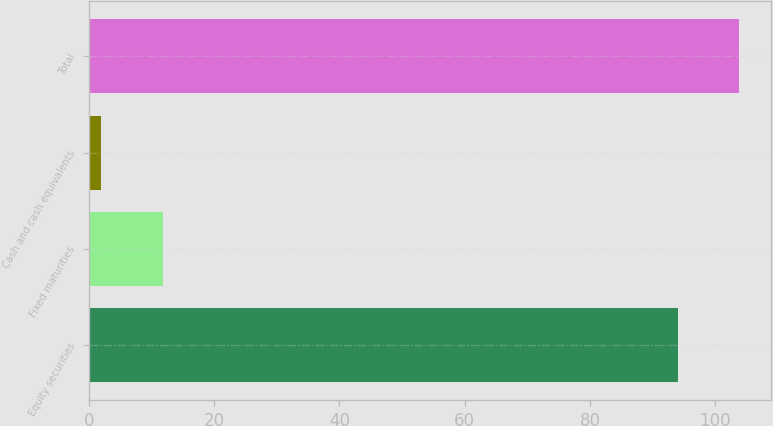Convert chart to OTSL. <chart><loc_0><loc_0><loc_500><loc_500><bar_chart><fcel>Equity securities<fcel>Fixed maturities<fcel>Cash and cash equivalents<fcel>Total<nl><fcel>94<fcel>11.8<fcel>2<fcel>103.8<nl></chart> 